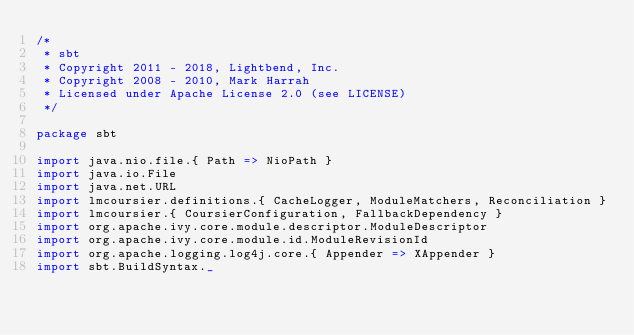Convert code to text. <code><loc_0><loc_0><loc_500><loc_500><_Scala_>/*
 * sbt
 * Copyright 2011 - 2018, Lightbend, Inc.
 * Copyright 2008 - 2010, Mark Harrah
 * Licensed under Apache License 2.0 (see LICENSE)
 */

package sbt

import java.nio.file.{ Path => NioPath }
import java.io.File
import java.net.URL
import lmcoursier.definitions.{ CacheLogger, ModuleMatchers, Reconciliation }
import lmcoursier.{ CoursierConfiguration, FallbackDependency }
import org.apache.ivy.core.module.descriptor.ModuleDescriptor
import org.apache.ivy.core.module.id.ModuleRevisionId
import org.apache.logging.log4j.core.{ Appender => XAppender }
import sbt.BuildSyntax._</code> 